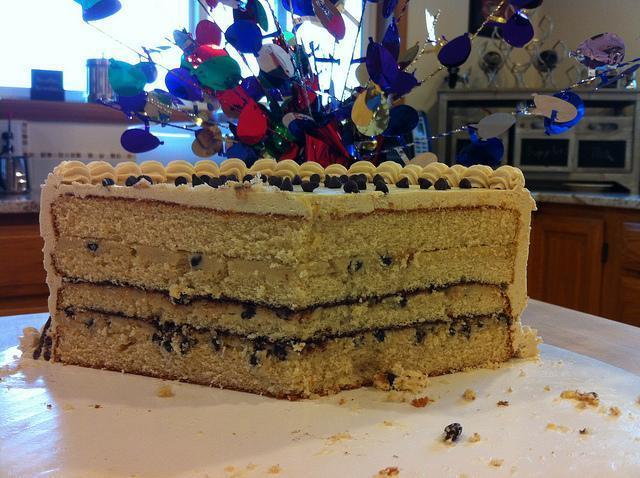How many layers of cake?
Give a very brief answer. 4. How many people are on the train?
Give a very brief answer. 0. 